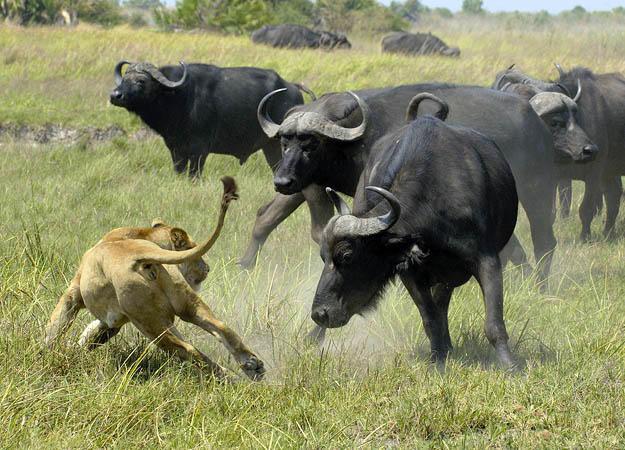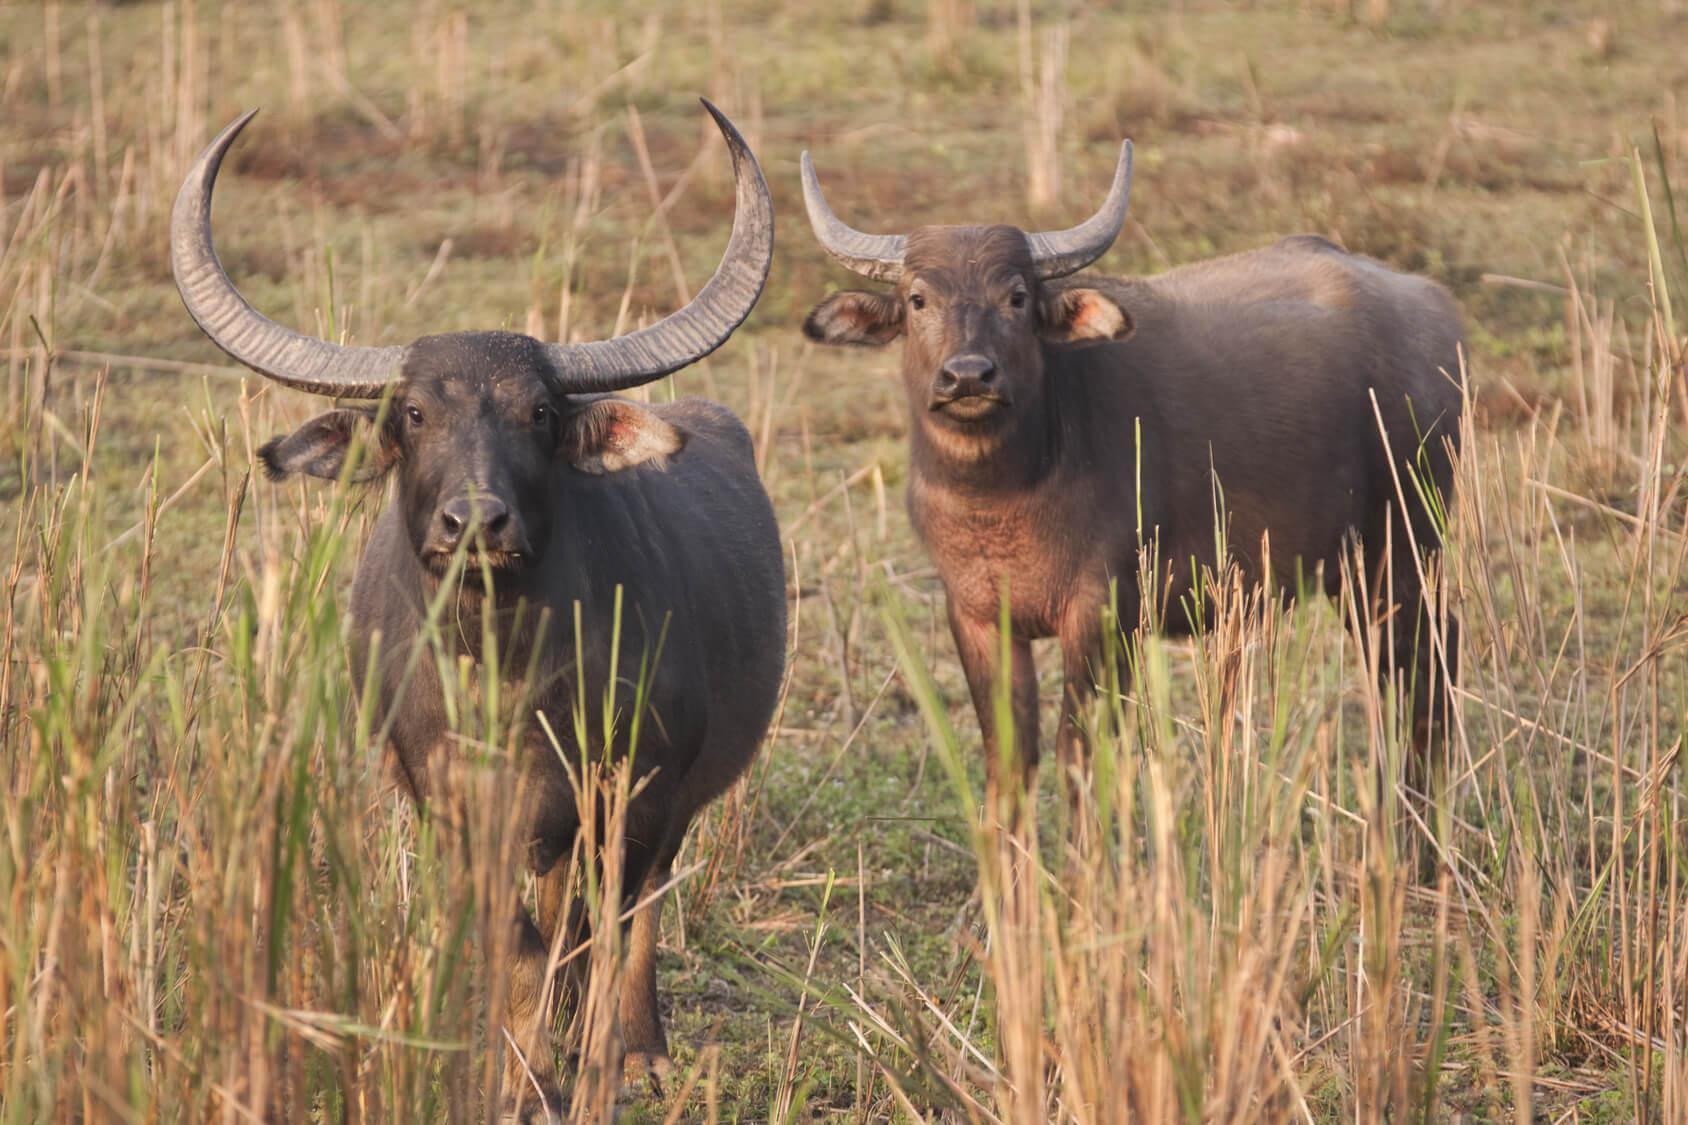The first image is the image on the left, the second image is the image on the right. Evaluate the accuracy of this statement regarding the images: "There is exactly one animal in the image on the right.". Is it true? Answer yes or no. No. The first image is the image on the left, the second image is the image on the right. Given the left and right images, does the statement "One of the images contains at least three water buffalo." hold true? Answer yes or no. Yes. 